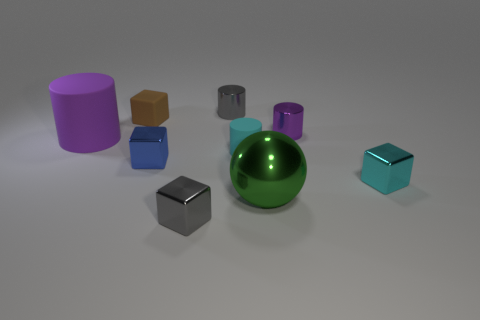Subtract all cyan cubes. How many cubes are left? 3 Subtract all cyan blocks. How many blocks are left? 3 Subtract all cylinders. How many objects are left? 5 Subtract 3 blocks. How many blocks are left? 1 Subtract all purple matte cylinders. Subtract all blue things. How many objects are left? 7 Add 7 small blue shiny cubes. How many small blue shiny cubes are left? 8 Add 5 gray metallic things. How many gray metallic things exist? 7 Add 1 cyan cubes. How many objects exist? 10 Subtract 0 red cylinders. How many objects are left? 9 Subtract all red cubes. Subtract all brown cylinders. How many cubes are left? 4 